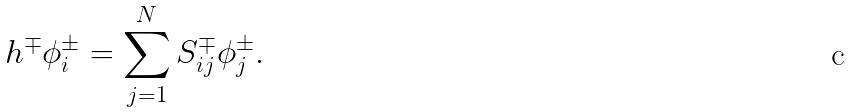<formula> <loc_0><loc_0><loc_500><loc_500>h ^ { \mp } \phi ^ { \pm } _ { i } = \sum _ { j = 1 } ^ { N } S ^ { \mp } _ { i j } \phi ^ { \pm } _ { j } .</formula> 